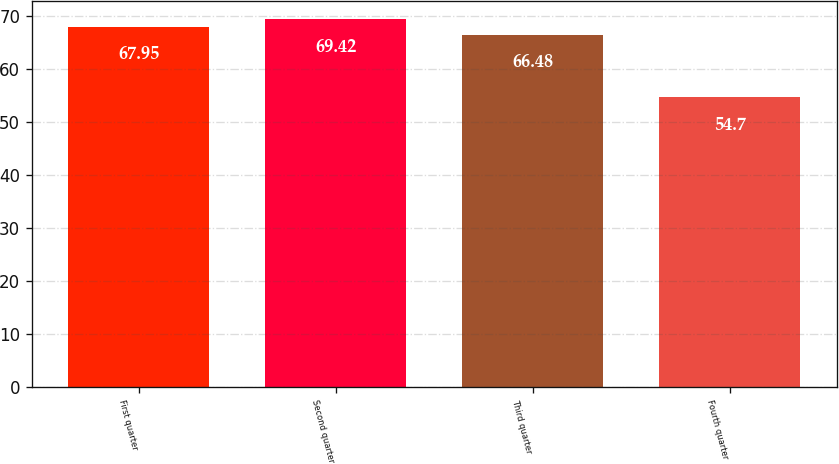<chart> <loc_0><loc_0><loc_500><loc_500><bar_chart><fcel>First quarter<fcel>Second quarter<fcel>Third quarter<fcel>Fourth quarter<nl><fcel>67.95<fcel>69.42<fcel>66.48<fcel>54.7<nl></chart> 